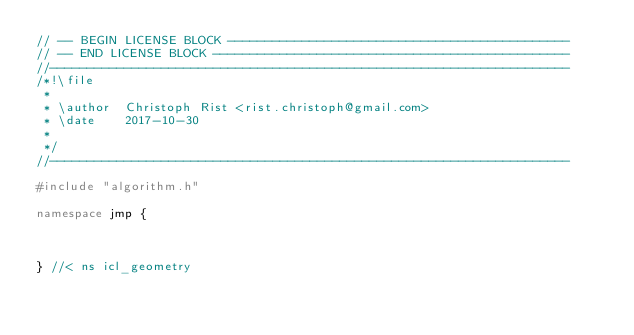<code> <loc_0><loc_0><loc_500><loc_500><_C++_>// -- BEGIN LICENSE BLOCK ----------------------------------------------
// -- END LICENSE BLOCK ------------------------------------------------
//----------------------------------------------------------------------
/*!\file
 *
 * \author  Christoph Rist <rist.christoph@gmail.com>
 * \date    2017-10-30
 *
 */
//----------------------------------------------------------------------

#include "algorithm.h"

namespace jmp {



} //< ns icl_geometry
</code> 